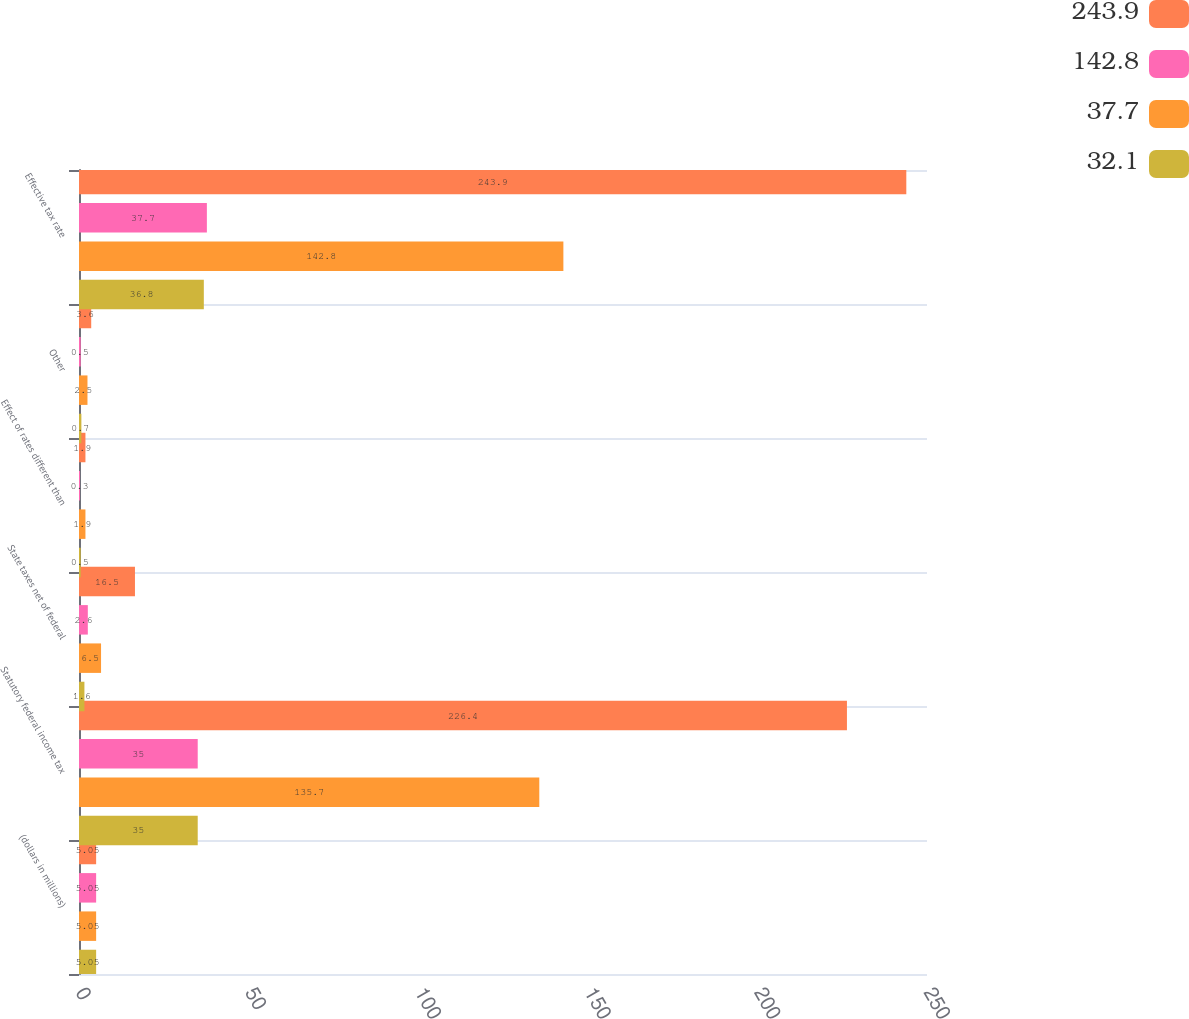Convert chart to OTSL. <chart><loc_0><loc_0><loc_500><loc_500><stacked_bar_chart><ecel><fcel>(dollars in millions)<fcel>Statutory federal income tax<fcel>State taxes net of federal<fcel>Effect of rates different than<fcel>Other<fcel>Effective tax rate<nl><fcel>243.9<fcel>5.05<fcel>226.4<fcel>16.5<fcel>1.9<fcel>3.6<fcel>243.9<nl><fcel>142.8<fcel>5.05<fcel>35<fcel>2.6<fcel>0.3<fcel>0.5<fcel>37.7<nl><fcel>37.7<fcel>5.05<fcel>135.7<fcel>6.5<fcel>1.9<fcel>2.5<fcel>142.8<nl><fcel>32.1<fcel>5.05<fcel>35<fcel>1.6<fcel>0.5<fcel>0.7<fcel>36.8<nl></chart> 